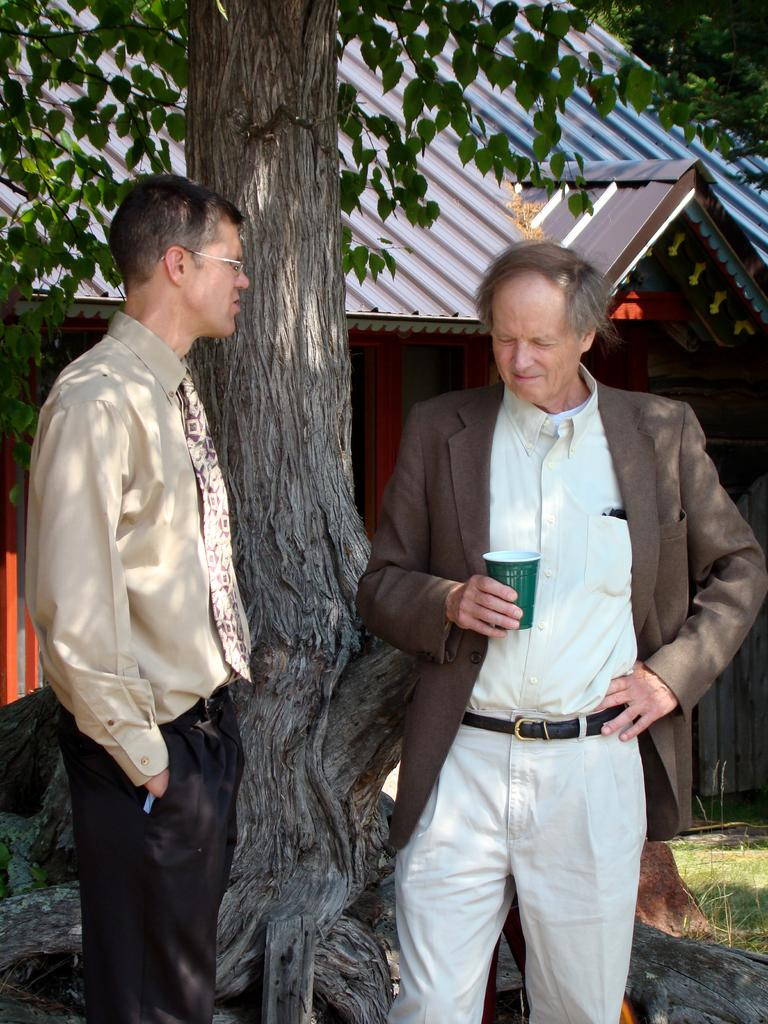How many people are in the image? There are two persons in the image. What is one of the persons holding? One person is holding a cup. What can be seen in the background behind the persons? There is a tree and a house visible behind the persons. What type of vegetation is present in the image? Grass is present in the bottom right corner of the image. What type of wheel can be seen on the lunch in the image? There is no lunch present in the image, and therefore no wheel associated with it. 